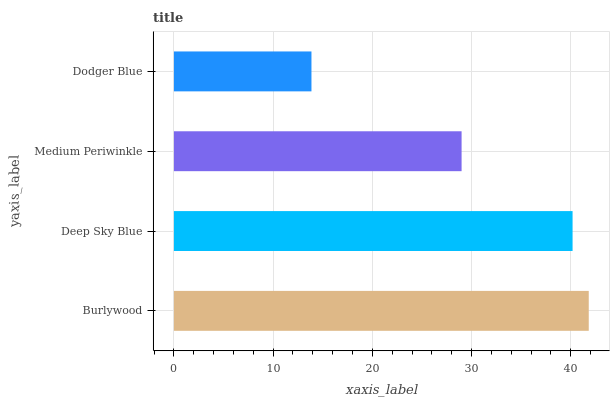Is Dodger Blue the minimum?
Answer yes or no. Yes. Is Burlywood the maximum?
Answer yes or no. Yes. Is Deep Sky Blue the minimum?
Answer yes or no. No. Is Deep Sky Blue the maximum?
Answer yes or no. No. Is Burlywood greater than Deep Sky Blue?
Answer yes or no. Yes. Is Deep Sky Blue less than Burlywood?
Answer yes or no. Yes. Is Deep Sky Blue greater than Burlywood?
Answer yes or no. No. Is Burlywood less than Deep Sky Blue?
Answer yes or no. No. Is Deep Sky Blue the high median?
Answer yes or no. Yes. Is Medium Periwinkle the low median?
Answer yes or no. Yes. Is Burlywood the high median?
Answer yes or no. No. Is Dodger Blue the low median?
Answer yes or no. No. 